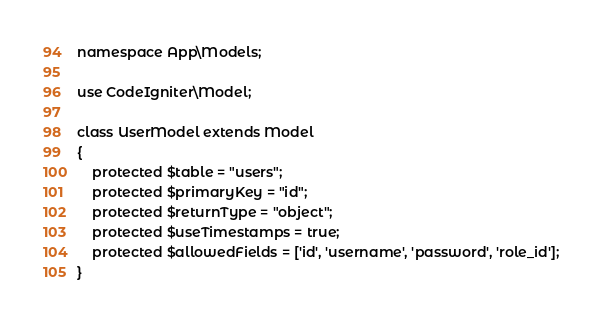Convert code to text. <code><loc_0><loc_0><loc_500><loc_500><_PHP_>
namespace App\Models;

use CodeIgniter\Model;

class UserModel extends Model
{
    protected $table = "users";
    protected $primaryKey = "id";
    protected $returnType = "object";
    protected $useTimestamps = true;
    protected $allowedFields = ['id', 'username', 'password', 'role_id'];
}
</code> 